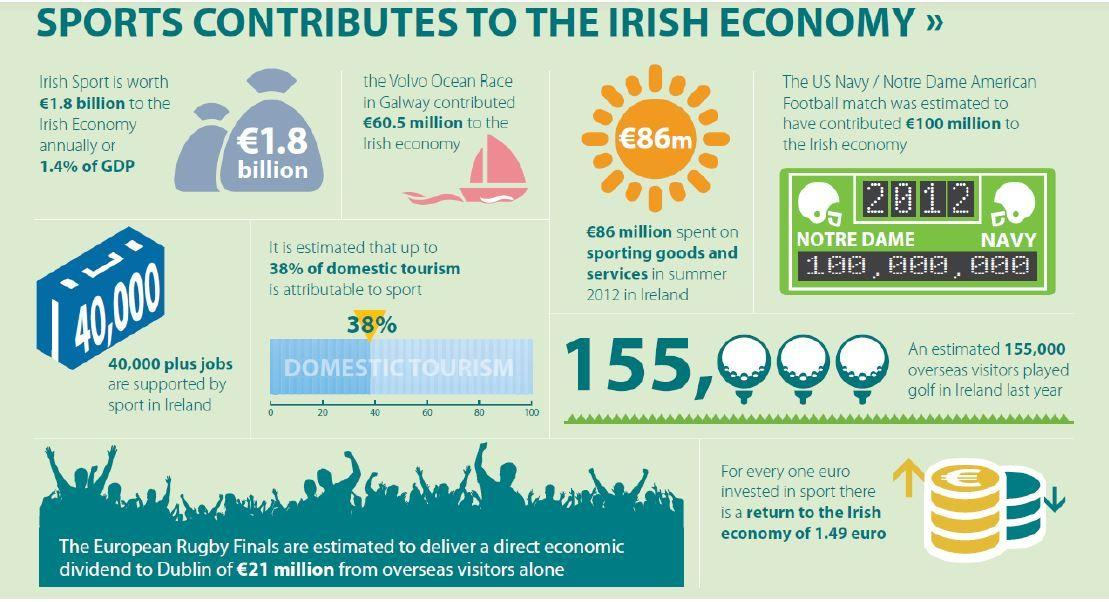Highlight a few significant elements in this photo. According to data, only 38% of domestic tourism can be attributed to sports. The US Navy and Notre Dame American football match was held in 2012. 